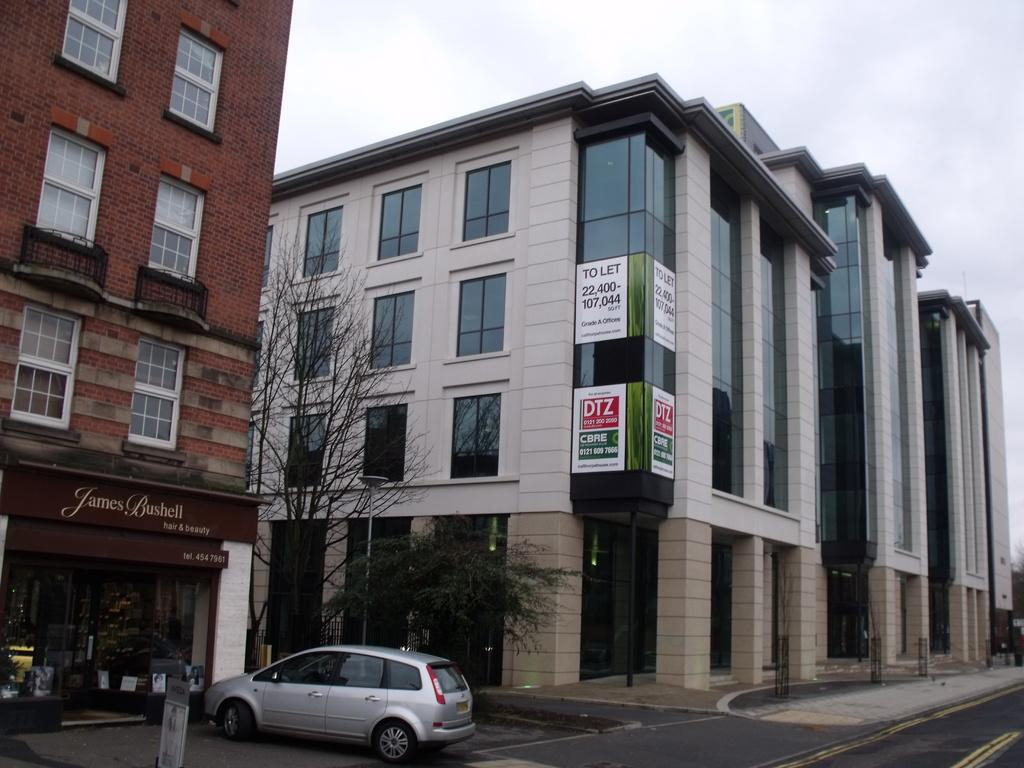What can be seen in the center of the image? There are buildings and trees in the center of the image. What is located in the foreground of the image? There are cars and a footpath in the foreground of the image. What type of surface is visible in the foreground of the image? There is a road in the foreground of the image. What is the condition of the sky in the image? The sky is cloudy in the image. Can you see any grass growing on the hat in the image? There is no hat present in the image, and therefore no grass growing on it. What type of grass is visible in the back of the image? There is no grass visible in the image, and the term "back" is not applicable to a two-dimensional image. 